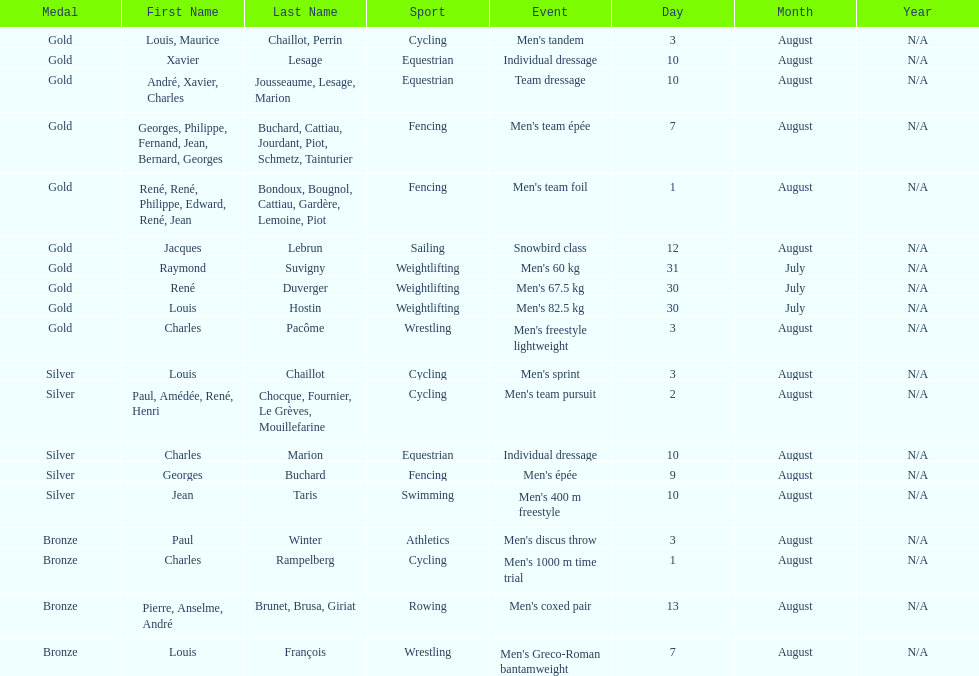Was there more gold medals won than silver? Yes. 